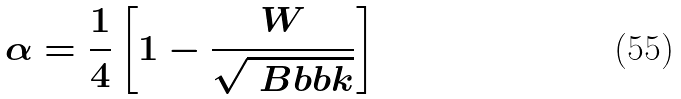Convert formula to latex. <formula><loc_0><loc_0><loc_500><loc_500>\alpha = \frac { 1 } { 4 } \left [ 1 - \frac { W } { \sqrt { \ B b b k } } \right ]</formula> 